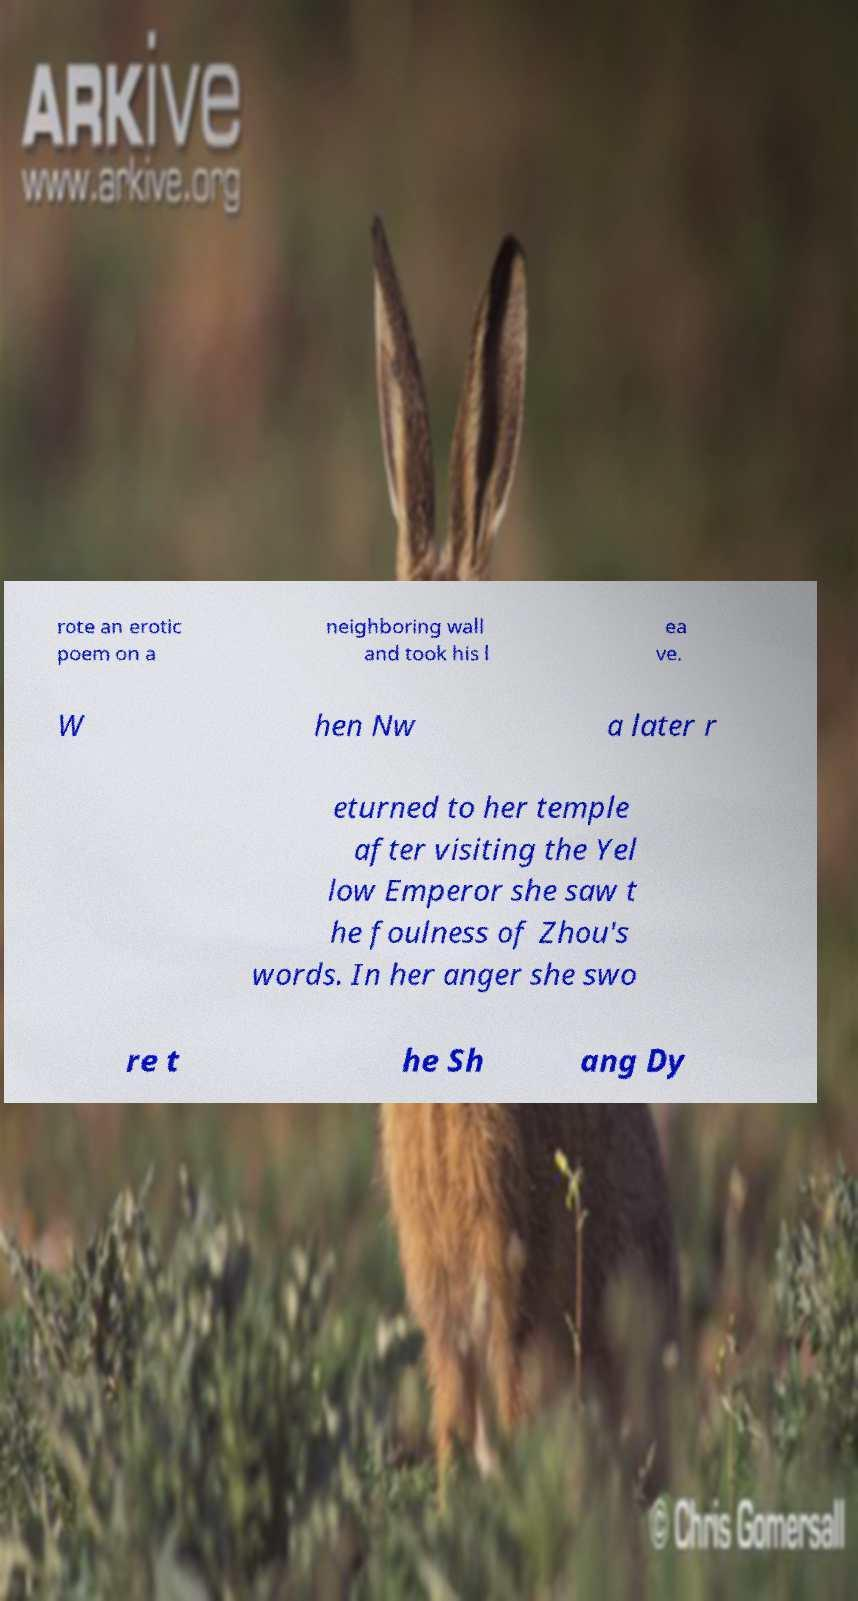Can you read and provide the text displayed in the image?This photo seems to have some interesting text. Can you extract and type it out for me? rote an erotic poem on a neighboring wall and took his l ea ve. W hen Nw a later r eturned to her temple after visiting the Yel low Emperor she saw t he foulness of Zhou's words. In her anger she swo re t he Sh ang Dy 